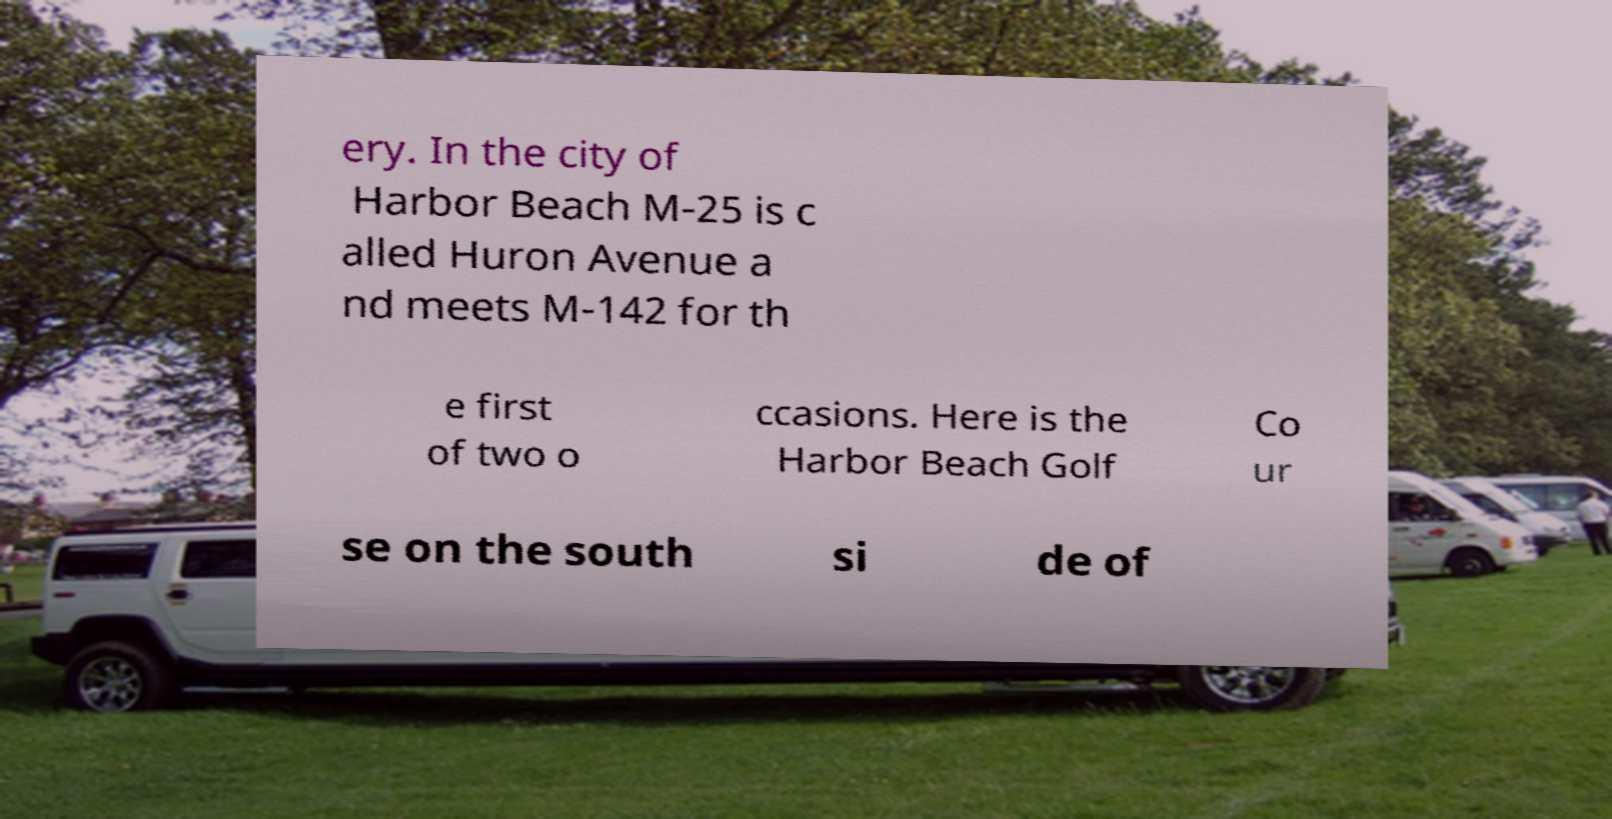Please read and relay the text visible in this image. What does it say? ery. In the city of Harbor Beach M-25 is c alled Huron Avenue a nd meets M-142 for th e first of two o ccasions. Here is the Harbor Beach Golf Co ur se on the south si de of 